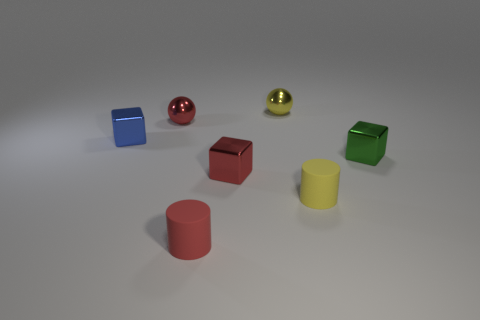Do the small red rubber thing and the metal thing that is to the right of the yellow rubber object have the same shape?
Your answer should be compact. No. Does the rubber cylinder right of the tiny yellow shiny ball have the same size as the yellow thing behind the tiny blue object?
Offer a terse response. Yes. How many other objects are the same shape as the small yellow rubber thing?
Provide a short and direct response. 1. There is a small yellow thing behind the cube that is left of the red cube; what is it made of?
Make the answer very short. Metal. How many rubber objects are either small spheres or large cyan balls?
Offer a terse response. 0. Is there any other thing that is the same material as the tiny blue block?
Make the answer very short. Yes. Is there a tiny green shiny thing to the left of the blue block in front of the yellow ball?
Your response must be concise. No. How many things are cylinders that are in front of the tiny red metal cube or red metallic things that are to the right of the tiny red ball?
Your response must be concise. 3. There is a shiny ball that is to the right of the tiny ball left of the rubber cylinder that is in front of the yellow matte cylinder; what is its color?
Ensure brevity in your answer.  Yellow. There is a red thing behind the green metallic cube to the right of the blue shiny cube; how big is it?
Ensure brevity in your answer.  Small. 